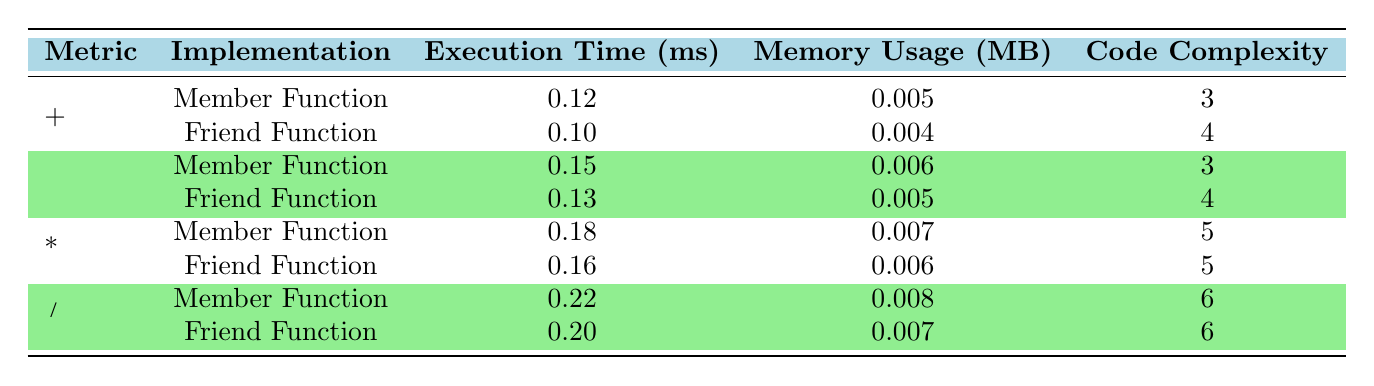What is the execution time for the friend function of the addition operator? The table shows the execution time for the friend function when using the addition operator as 0.10 ms.
Answer: 0.10 ms Which implementation type for operator overloading has the highest memory usage? By inspecting the memory usage values across all implementations, the member function for the division operator has the highest memory usage at 0.008 MB.
Answer: 0.008 MB What is the difference in execution time between the member function and the friend function for the subtraction operator? The execution time for the member function is 0.15 ms and for the friend function, it is 0.13 ms. Calculating the difference: 0.15 ms - 0.13 ms = 0.02 ms.
Answer: 0.02 ms Is the code complexity for the multiplication operator implemented as a member function greater than or equal to that of the friend function? The code complexity for the multiplication operator using a member function is 5 and for the friend function is also 5, therefore it is equal.
Answer: Yes What is the average execution time across all implementations? The total execution time is (0.12 + 0.10 + 0.15 + 0.13 + 0.18 + 0.16 + 0.22 + 0.20) = 1.16 ms and there are 8 implementations, so the average execution time is 1.16 ms / 8 = 0.145 ms.
Answer: 0.145 ms Which operator has the least execution time when implemented as a friend function? Looking at the friend function executions, the addition operator has the least execution time at 0.10 ms.
Answer: Addition operator What is the largest code complexity for any operator overload in the table? The largest code complexity value in the table is 6, which occurs for both the division operator implementations.
Answer: 6 Is the memory usage for the friend function implementation less than that of the member function for the addition operator? The memory usage for the friend function is 0.004 MB, while for the member function is 0.005 MB, confirming that the friend function uses less memory.
Answer: Yes 